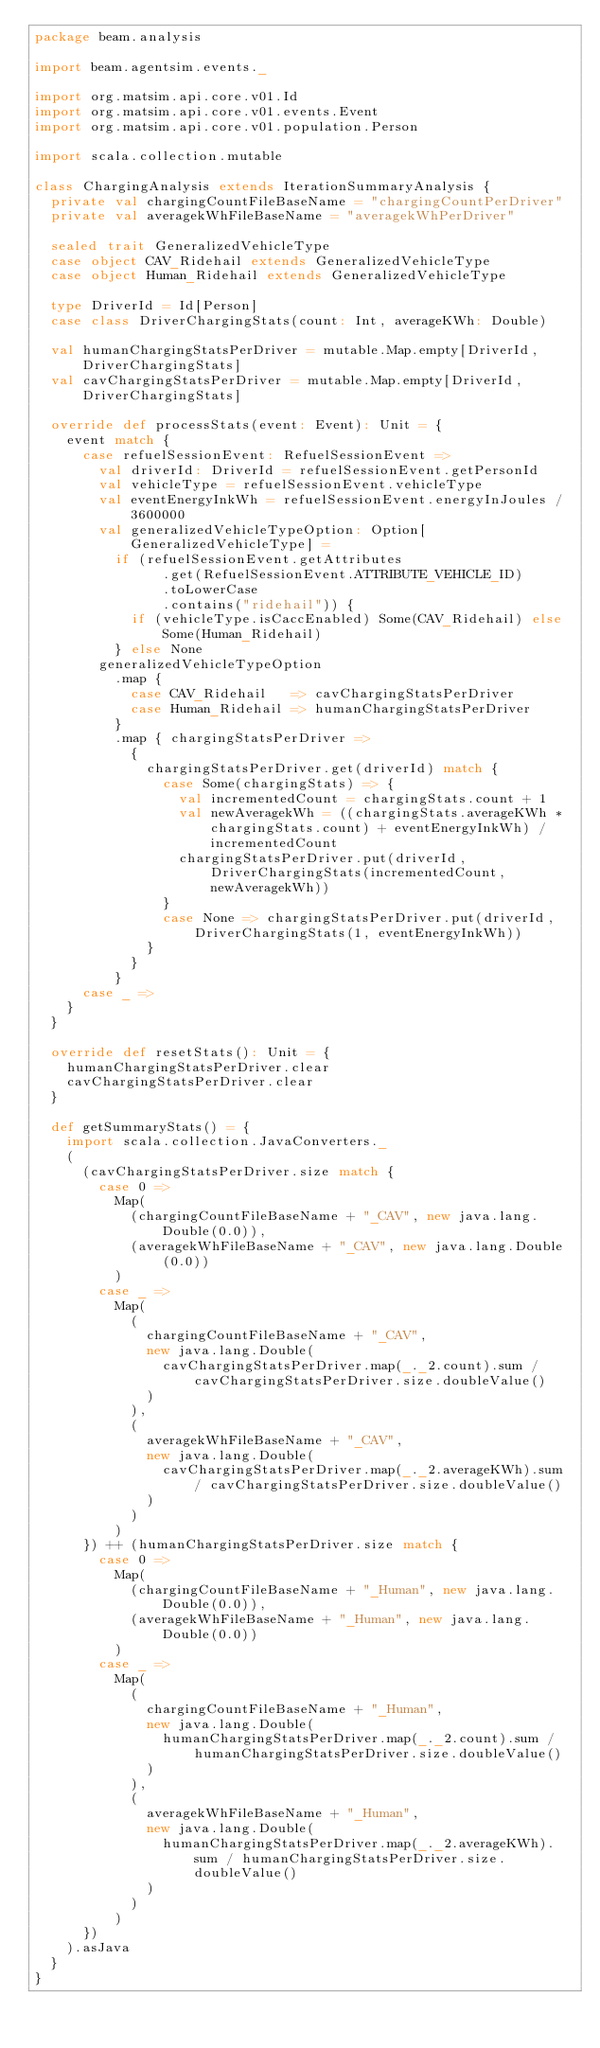Convert code to text. <code><loc_0><loc_0><loc_500><loc_500><_Scala_>package beam.analysis

import beam.agentsim.events._

import org.matsim.api.core.v01.Id
import org.matsim.api.core.v01.events.Event
import org.matsim.api.core.v01.population.Person

import scala.collection.mutable

class ChargingAnalysis extends IterationSummaryAnalysis {
  private val chargingCountFileBaseName = "chargingCountPerDriver"
  private val averagekWhFileBaseName = "averagekWhPerDriver"

  sealed trait GeneralizedVehicleType
  case object CAV_Ridehail extends GeneralizedVehicleType
  case object Human_Ridehail extends GeneralizedVehicleType

  type DriverId = Id[Person]
  case class DriverChargingStats(count: Int, averageKWh: Double)

  val humanChargingStatsPerDriver = mutable.Map.empty[DriverId, DriverChargingStats]
  val cavChargingStatsPerDriver = mutable.Map.empty[DriverId, DriverChargingStats]

  override def processStats(event: Event): Unit = {
    event match {
      case refuelSessionEvent: RefuelSessionEvent =>
        val driverId: DriverId = refuelSessionEvent.getPersonId
        val vehicleType = refuelSessionEvent.vehicleType
        val eventEnergyInkWh = refuelSessionEvent.energyInJoules / 3600000
        val generalizedVehicleTypeOption: Option[GeneralizedVehicleType] =
          if (refuelSessionEvent.getAttributes
                .get(RefuelSessionEvent.ATTRIBUTE_VEHICLE_ID)
                .toLowerCase
                .contains("ridehail")) {
            if (vehicleType.isCaccEnabled) Some(CAV_Ridehail) else Some(Human_Ridehail)
          } else None
        generalizedVehicleTypeOption
          .map {
            case CAV_Ridehail   => cavChargingStatsPerDriver
            case Human_Ridehail => humanChargingStatsPerDriver
          }
          .map { chargingStatsPerDriver =>
            {
              chargingStatsPerDriver.get(driverId) match {
                case Some(chargingStats) => {
                  val incrementedCount = chargingStats.count + 1
                  val newAveragekWh = ((chargingStats.averageKWh * chargingStats.count) + eventEnergyInkWh) / incrementedCount
                  chargingStatsPerDriver.put(driverId, DriverChargingStats(incrementedCount, newAveragekWh))
                }
                case None => chargingStatsPerDriver.put(driverId, DriverChargingStats(1, eventEnergyInkWh))
              }
            }
          }
      case _ =>
    }
  }

  override def resetStats(): Unit = {
    humanChargingStatsPerDriver.clear
    cavChargingStatsPerDriver.clear
  }

  def getSummaryStats() = {
    import scala.collection.JavaConverters._
    (
      (cavChargingStatsPerDriver.size match {
        case 0 =>
          Map(
            (chargingCountFileBaseName + "_CAV", new java.lang.Double(0.0)),
            (averagekWhFileBaseName + "_CAV", new java.lang.Double(0.0))
          )
        case _ =>
          Map(
            (
              chargingCountFileBaseName + "_CAV",
              new java.lang.Double(
                cavChargingStatsPerDriver.map(_._2.count).sum / cavChargingStatsPerDriver.size.doubleValue()
              )
            ),
            (
              averagekWhFileBaseName + "_CAV",
              new java.lang.Double(
                cavChargingStatsPerDriver.map(_._2.averageKWh).sum / cavChargingStatsPerDriver.size.doubleValue()
              )
            )
          )
      }) ++ (humanChargingStatsPerDriver.size match {
        case 0 =>
          Map(
            (chargingCountFileBaseName + "_Human", new java.lang.Double(0.0)),
            (averagekWhFileBaseName + "_Human", new java.lang.Double(0.0))
          )
        case _ =>
          Map(
            (
              chargingCountFileBaseName + "_Human",
              new java.lang.Double(
                humanChargingStatsPerDriver.map(_._2.count).sum / humanChargingStatsPerDriver.size.doubleValue()
              )
            ),
            (
              averagekWhFileBaseName + "_Human",
              new java.lang.Double(
                humanChargingStatsPerDriver.map(_._2.averageKWh).sum / humanChargingStatsPerDriver.size.doubleValue()
              )
            )
          )
      })
    ).asJava
  }
}
</code> 